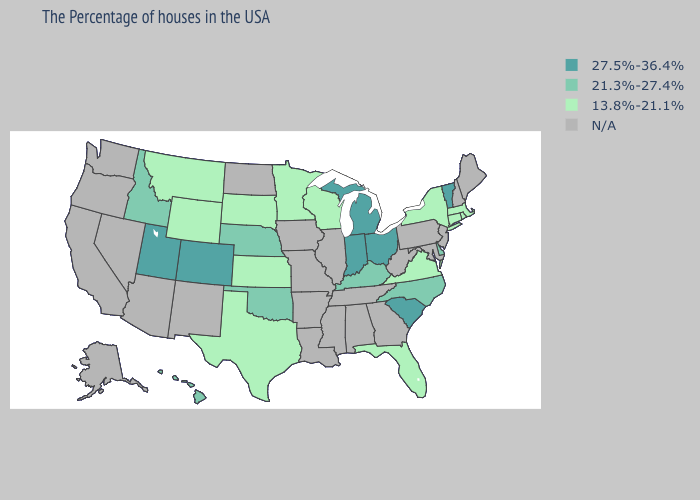Which states have the highest value in the USA?
Quick response, please. Vermont, South Carolina, Ohio, Michigan, Indiana, Colorado, Utah. What is the highest value in states that border Iowa?
Write a very short answer. 21.3%-27.4%. Name the states that have a value in the range 21.3%-27.4%?
Keep it brief. Delaware, North Carolina, Kentucky, Nebraska, Oklahoma, Idaho, Hawaii. Does Texas have the lowest value in the USA?
Give a very brief answer. Yes. Which states have the lowest value in the Northeast?
Short answer required. Massachusetts, Rhode Island, Connecticut, New York. Which states have the lowest value in the USA?
Keep it brief. Massachusetts, Rhode Island, Connecticut, New York, Virginia, Florida, Wisconsin, Minnesota, Kansas, Texas, South Dakota, Wyoming, Montana. Name the states that have a value in the range 13.8%-21.1%?
Write a very short answer. Massachusetts, Rhode Island, Connecticut, New York, Virginia, Florida, Wisconsin, Minnesota, Kansas, Texas, South Dakota, Wyoming, Montana. What is the value of Oregon?
Give a very brief answer. N/A. What is the value of Colorado?
Write a very short answer. 27.5%-36.4%. What is the value of Ohio?
Short answer required. 27.5%-36.4%. What is the highest value in the USA?
Answer briefly. 27.5%-36.4%. Name the states that have a value in the range N/A?
Keep it brief. Maine, New Hampshire, New Jersey, Maryland, Pennsylvania, West Virginia, Georgia, Alabama, Tennessee, Illinois, Mississippi, Louisiana, Missouri, Arkansas, Iowa, North Dakota, New Mexico, Arizona, Nevada, California, Washington, Oregon, Alaska. 